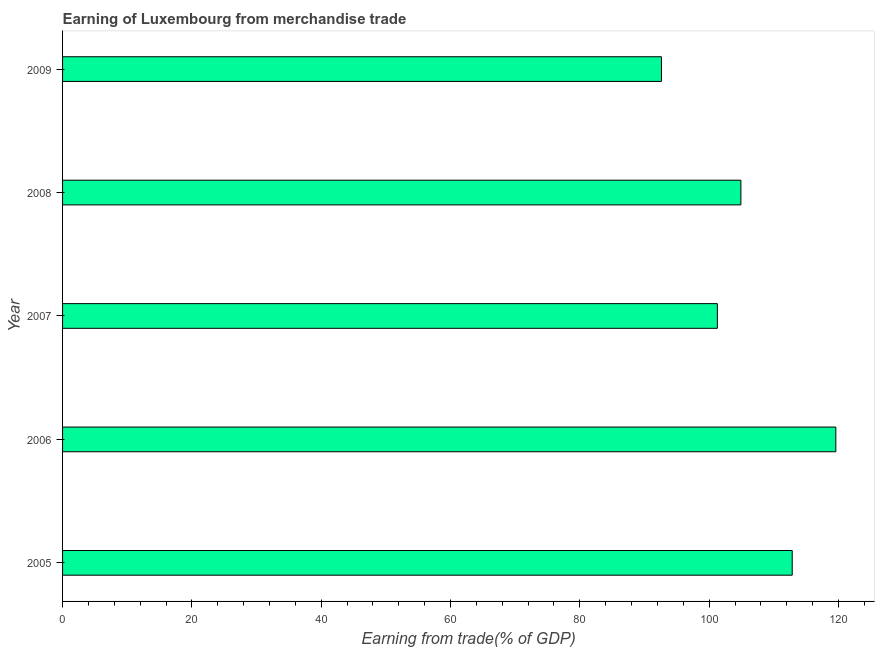What is the title of the graph?
Provide a short and direct response. Earning of Luxembourg from merchandise trade. What is the label or title of the X-axis?
Keep it short and to the point. Earning from trade(% of GDP). What is the earning from merchandise trade in 2005?
Your response must be concise. 112.85. Across all years, what is the maximum earning from merchandise trade?
Your answer should be very brief. 119.59. Across all years, what is the minimum earning from merchandise trade?
Offer a very short reply. 92.62. What is the sum of the earning from merchandise trade?
Offer a very short reply. 531.23. What is the difference between the earning from merchandise trade in 2005 and 2009?
Keep it short and to the point. 20.22. What is the average earning from merchandise trade per year?
Your answer should be compact. 106.25. What is the median earning from merchandise trade?
Offer a terse response. 104.91. Do a majority of the years between 2008 and 2009 (inclusive) have earning from merchandise trade greater than 76 %?
Ensure brevity in your answer.  Yes. What is the ratio of the earning from merchandise trade in 2008 to that in 2009?
Your answer should be very brief. 1.13. Is the earning from merchandise trade in 2007 less than that in 2008?
Keep it short and to the point. Yes. Is the difference between the earning from merchandise trade in 2005 and 2008 greater than the difference between any two years?
Make the answer very short. No. What is the difference between the highest and the second highest earning from merchandise trade?
Give a very brief answer. 6.74. Is the sum of the earning from merchandise trade in 2005 and 2008 greater than the maximum earning from merchandise trade across all years?
Offer a very short reply. Yes. What is the difference between the highest and the lowest earning from merchandise trade?
Provide a succinct answer. 26.97. In how many years, is the earning from merchandise trade greater than the average earning from merchandise trade taken over all years?
Give a very brief answer. 2. What is the Earning from trade(% of GDP) of 2005?
Offer a very short reply. 112.85. What is the Earning from trade(% of GDP) in 2006?
Your answer should be very brief. 119.59. What is the Earning from trade(% of GDP) in 2007?
Keep it short and to the point. 101.27. What is the Earning from trade(% of GDP) in 2008?
Your response must be concise. 104.91. What is the Earning from trade(% of GDP) in 2009?
Ensure brevity in your answer.  92.62. What is the difference between the Earning from trade(% of GDP) in 2005 and 2006?
Offer a terse response. -6.74. What is the difference between the Earning from trade(% of GDP) in 2005 and 2007?
Offer a very short reply. 11.58. What is the difference between the Earning from trade(% of GDP) in 2005 and 2008?
Keep it short and to the point. 7.94. What is the difference between the Earning from trade(% of GDP) in 2005 and 2009?
Your answer should be very brief. 20.22. What is the difference between the Earning from trade(% of GDP) in 2006 and 2007?
Keep it short and to the point. 18.32. What is the difference between the Earning from trade(% of GDP) in 2006 and 2008?
Provide a succinct answer. 14.68. What is the difference between the Earning from trade(% of GDP) in 2006 and 2009?
Ensure brevity in your answer.  26.97. What is the difference between the Earning from trade(% of GDP) in 2007 and 2008?
Give a very brief answer. -3.64. What is the difference between the Earning from trade(% of GDP) in 2007 and 2009?
Ensure brevity in your answer.  8.65. What is the difference between the Earning from trade(% of GDP) in 2008 and 2009?
Keep it short and to the point. 12.29. What is the ratio of the Earning from trade(% of GDP) in 2005 to that in 2006?
Your answer should be compact. 0.94. What is the ratio of the Earning from trade(% of GDP) in 2005 to that in 2007?
Your answer should be very brief. 1.11. What is the ratio of the Earning from trade(% of GDP) in 2005 to that in 2008?
Give a very brief answer. 1.08. What is the ratio of the Earning from trade(% of GDP) in 2005 to that in 2009?
Offer a terse response. 1.22. What is the ratio of the Earning from trade(% of GDP) in 2006 to that in 2007?
Your answer should be compact. 1.18. What is the ratio of the Earning from trade(% of GDP) in 2006 to that in 2008?
Your answer should be very brief. 1.14. What is the ratio of the Earning from trade(% of GDP) in 2006 to that in 2009?
Ensure brevity in your answer.  1.29. What is the ratio of the Earning from trade(% of GDP) in 2007 to that in 2008?
Your answer should be compact. 0.96. What is the ratio of the Earning from trade(% of GDP) in 2007 to that in 2009?
Provide a succinct answer. 1.09. What is the ratio of the Earning from trade(% of GDP) in 2008 to that in 2009?
Give a very brief answer. 1.13. 